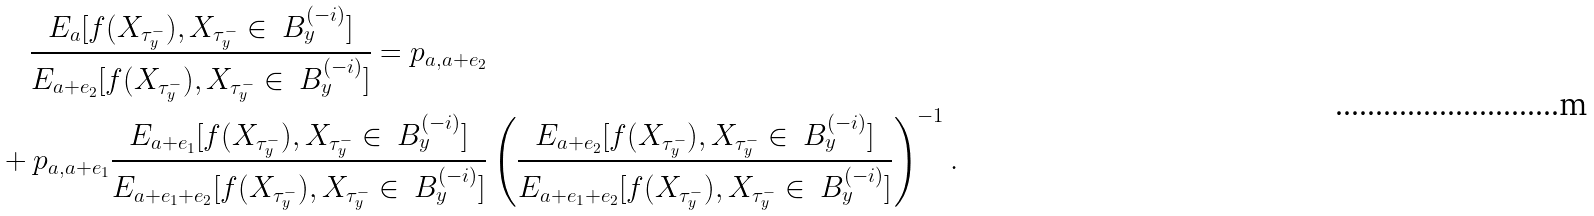Convert formula to latex. <formula><loc_0><loc_0><loc_500><loc_500>& \quad \frac { { E _ { a } [ f ( X _ { \tau ^ { - } _ { y } } ) , X _ { \tau ^ { - } _ { y } } \in \ B ^ { ( - i ) } _ { y } ] } } { { E _ { a + e _ { 2 } } [ f ( X _ { \tau ^ { - } _ { y } } ) , X _ { \tau ^ { - } _ { y } } \in \ B ^ { ( - i ) } _ { y } ] } } = p _ { a , a + e _ { 2 } } \\ & + p _ { a , a + e _ { 1 } } \frac { { E _ { a + e _ { 1 } } [ f ( X _ { \tau ^ { - } _ { y } } ) , X _ { \tau ^ { - } _ { y } } \in \ B ^ { ( - i ) } _ { y } ] } } { { E _ { a + e _ { 1 } + e _ { 2 } } [ f ( X _ { \tau ^ { - } _ { y } } ) , X _ { \tau ^ { - } _ { y } } \in \ B ^ { ( - i ) } _ { y } ] } } \left ( \frac { { E _ { a + e _ { 2 } } [ f ( X _ { \tau ^ { - } _ { y } } ) , X _ { \tau ^ { - } _ { y } } \in \ B ^ { ( - i ) } _ { y } ] } } { { E _ { a + e _ { 1 } + e _ { 2 } } [ f ( X _ { \tau ^ { - } _ { y } } ) , X _ { \tau ^ { - } _ { y } } \in \ B ^ { ( - i ) } _ { y } ] } } \right ) ^ { - 1 } .</formula> 